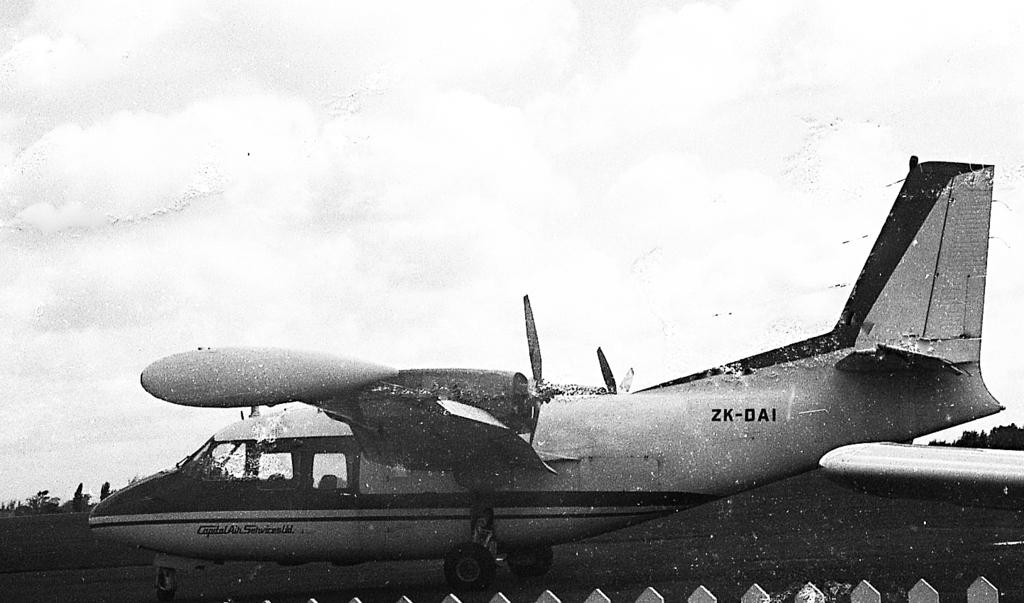<image>
Give a short and clear explanation of the subsequent image. An airplane with ZK DAI on the rear of the plane. 